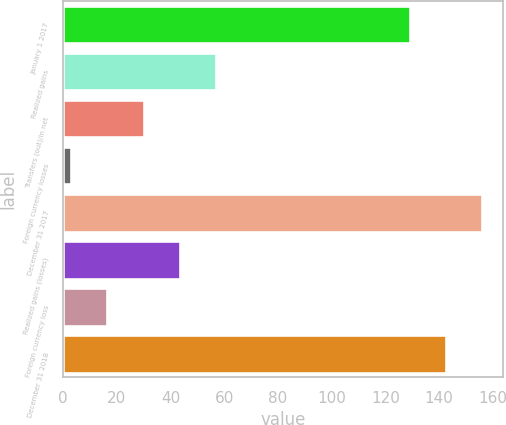Convert chart. <chart><loc_0><loc_0><loc_500><loc_500><bar_chart><fcel>January 1 2017<fcel>Realized gains<fcel>Transfers (out)/in net<fcel>Foreign currency losses<fcel>December 31 2017<fcel>Realized gains (losses)<fcel>Foreign currency loss<fcel>December 31 2018<nl><fcel>129<fcel>57<fcel>30<fcel>3<fcel>156<fcel>43.5<fcel>16.5<fcel>142.5<nl></chart> 